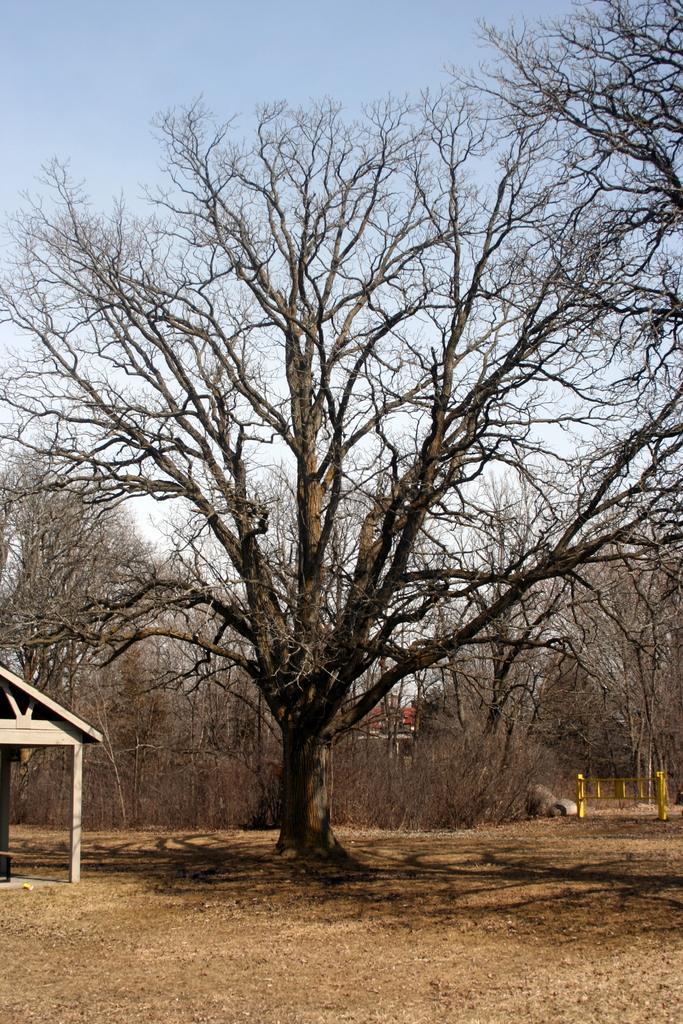Please provide a concise description of this image. In this picture we can see trees, ground, shed and fence. In the background of the image we can see the sky. 